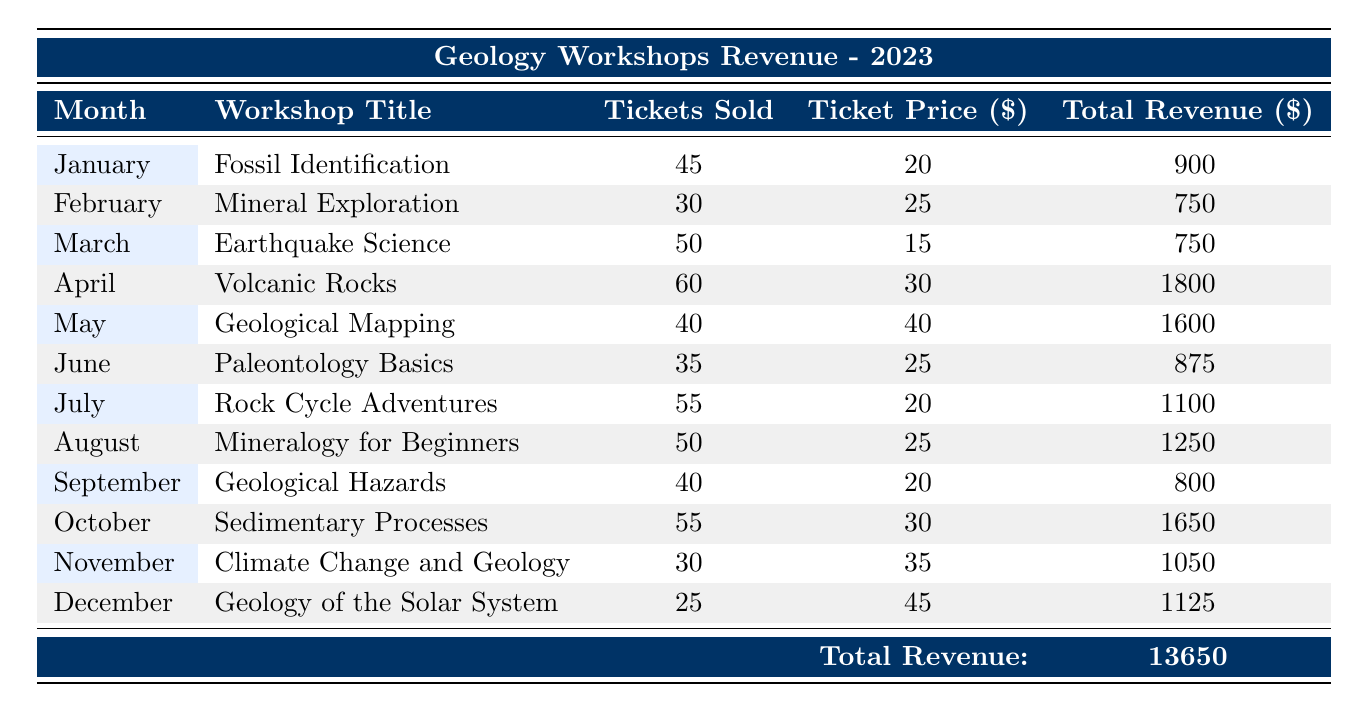What was the total revenue generated in April? In April, the workshop titled "Volcanic Rocks" had a total revenue of 1800.
Answer: 1800 Which month had the highest ticket sales? In April, there were 60 tickets sold for the workshop "Volcanic Rocks," which is the highest number of ticket sales for any month.
Answer: April What is the combined total revenue of workshops held in June and September? The total revenue in June was 875, and in September, it was 800. Adding these two amounts gives 875 + 800 = 1675.
Answer: 1675 Is the ticket price for the "Fossil Identification" workshop higher than that for the "Geological Hazards" workshop? The ticket price for "Fossil Identification" is 20, while for "Geological Hazards" it is also 20. Therefore, they are equal, not higher.
Answer: No What is the average ticket price across all workshops? To find the average, first list the ticket prices: 20, 25, 15, 30, 40, 25, 20, 25, 20, 30, 35, and 45. There are 12 workshops, and the total ticket price is 20+25+15+30+40+25+20+25+20+30+35+45 = 365. The average is 365/12 = 30.42 (approximately).
Answer: 30.42 Which workshop generated the least revenue in 2023? The workshop "Mineral Exploration" in February generated the least revenue, with a total of 750.
Answer: Mineral Exploration How many workshops had ticket sales greater than 50? The workshops "Volcanic Rocks," "Rock Cycle Adventures," and "Sedimentary Processes" had ticket sales greater than 50, specifically 60, 55, and 55 tickets sold respectively. This totals 3 workshops.
Answer: 3 What was the total revenue across all workshops in 2023? By combining the total revenue from each month's workshop, we find that the total across all months is 900 + 750 + 750 + 1800 + 1600 + 875 + 1100 + 1250 + 800 + 1650 + 1050 + 1125 = 13650.
Answer: 13650 